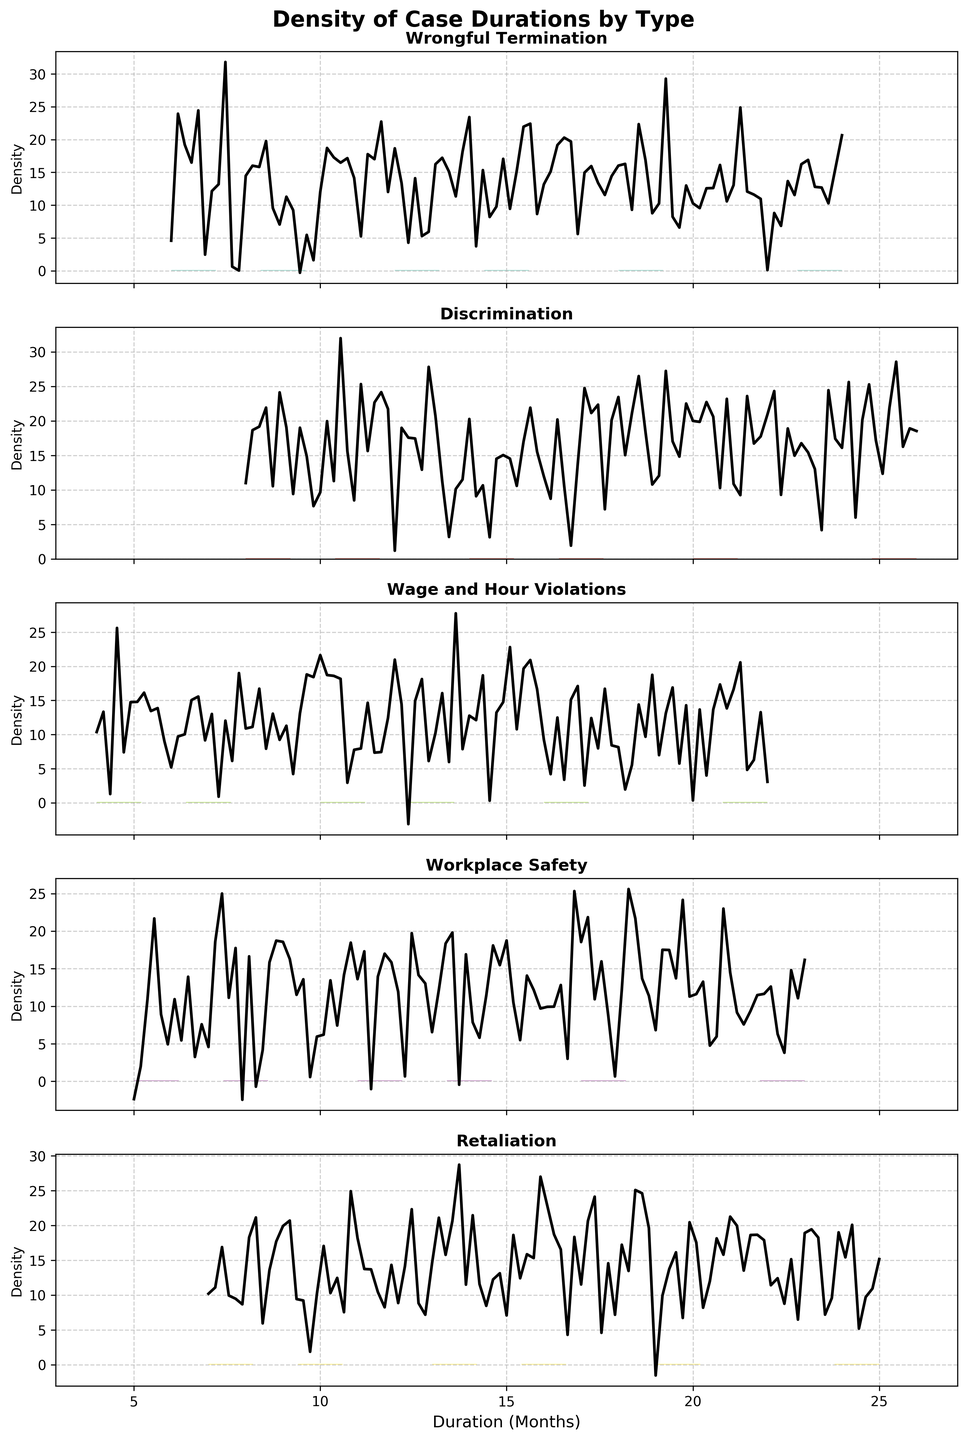Is the title of the figure clear and indicative of its content? The title of the figure is "Density of Case Durations by Type," which clearly describes that the figure shows the density distributions of case durations for different types of employment-related lawsuits.
Answer: Yes What is the color scheme used in the plots? Each subplot uses a distinct color from a gradient color scheme, likely from a colormap, to differentiate between the different types of cases.
Answer: Distinct colors How many different case types are displayed in the subplots? By counting the individual subplots, we can identify that there are six different case types displayed in the figure.
Answer: Six Which case type appears to have the shortest average duration? By comparing the peak positions of the density plots, the "Wage and Hour Violations" case type appears to have the shortest average duration, as its peak is around the 7-month mark.
Answer: Wage and Hour Violations Which case type appears to have the longest average duration? By examining the density plots, the "Retaliation" case type seems to have the longest average duration, with its peak closer to the 16-month mark.
Answer: Retaliation How does the density plot for "Wrongful Termination" compare to the plot for "Discrimination"? The density plot for "Wrongful Termination" shows a distribution peaking around the 12-month mark, whereas the "Discrimination" plot peaks slightly earlier around the 11-month mark, indicating marginally shorter case durations for "Discrimination."
Answer: Wrongful Termination peaks later What case type has the least spread in its case duration data? The case type "Wage and Hour Violations" appears to have the least spread, evidenced by its narrow and sharp peak around 10 months, indicating less variability in the case durations.
Answer: Wage and Hour Violations Are the case durations for "Workplace Safety" evenly distributed? The density plot for "Workplace Safety" shows multiple peaks, suggesting that the case durations are not evenly distributed and have several common length intervals.
Answer: Not evenly distributed Do any case types have significant outliers? The density plot does not explicitly show individual data points, but "Retaliation" has a relatively more spread-out distribution, indicating possible outliers affecting the overall density.
Answer: Retaliation may have outliers 